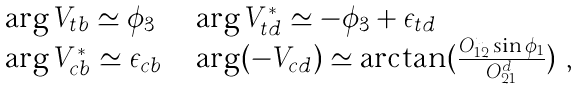<formula> <loc_0><loc_0><loc_500><loc_500>\begin{array} { l l l } \arg V _ { t b } \simeq \phi _ { 3 } & & \arg V _ { t d } ^ { * } \simeq - \phi _ { 3 } + \epsilon _ { t d } \\ \arg V _ { c b } ^ { * } \simeq \epsilon _ { c b } & & \arg ( - V _ { c d } ) \simeq \arctan ( \frac { O _ { 1 2 } ^ { u } \sin \phi _ { 1 } } { O _ { 2 1 } ^ { d } } ) \ , \end{array}</formula> 